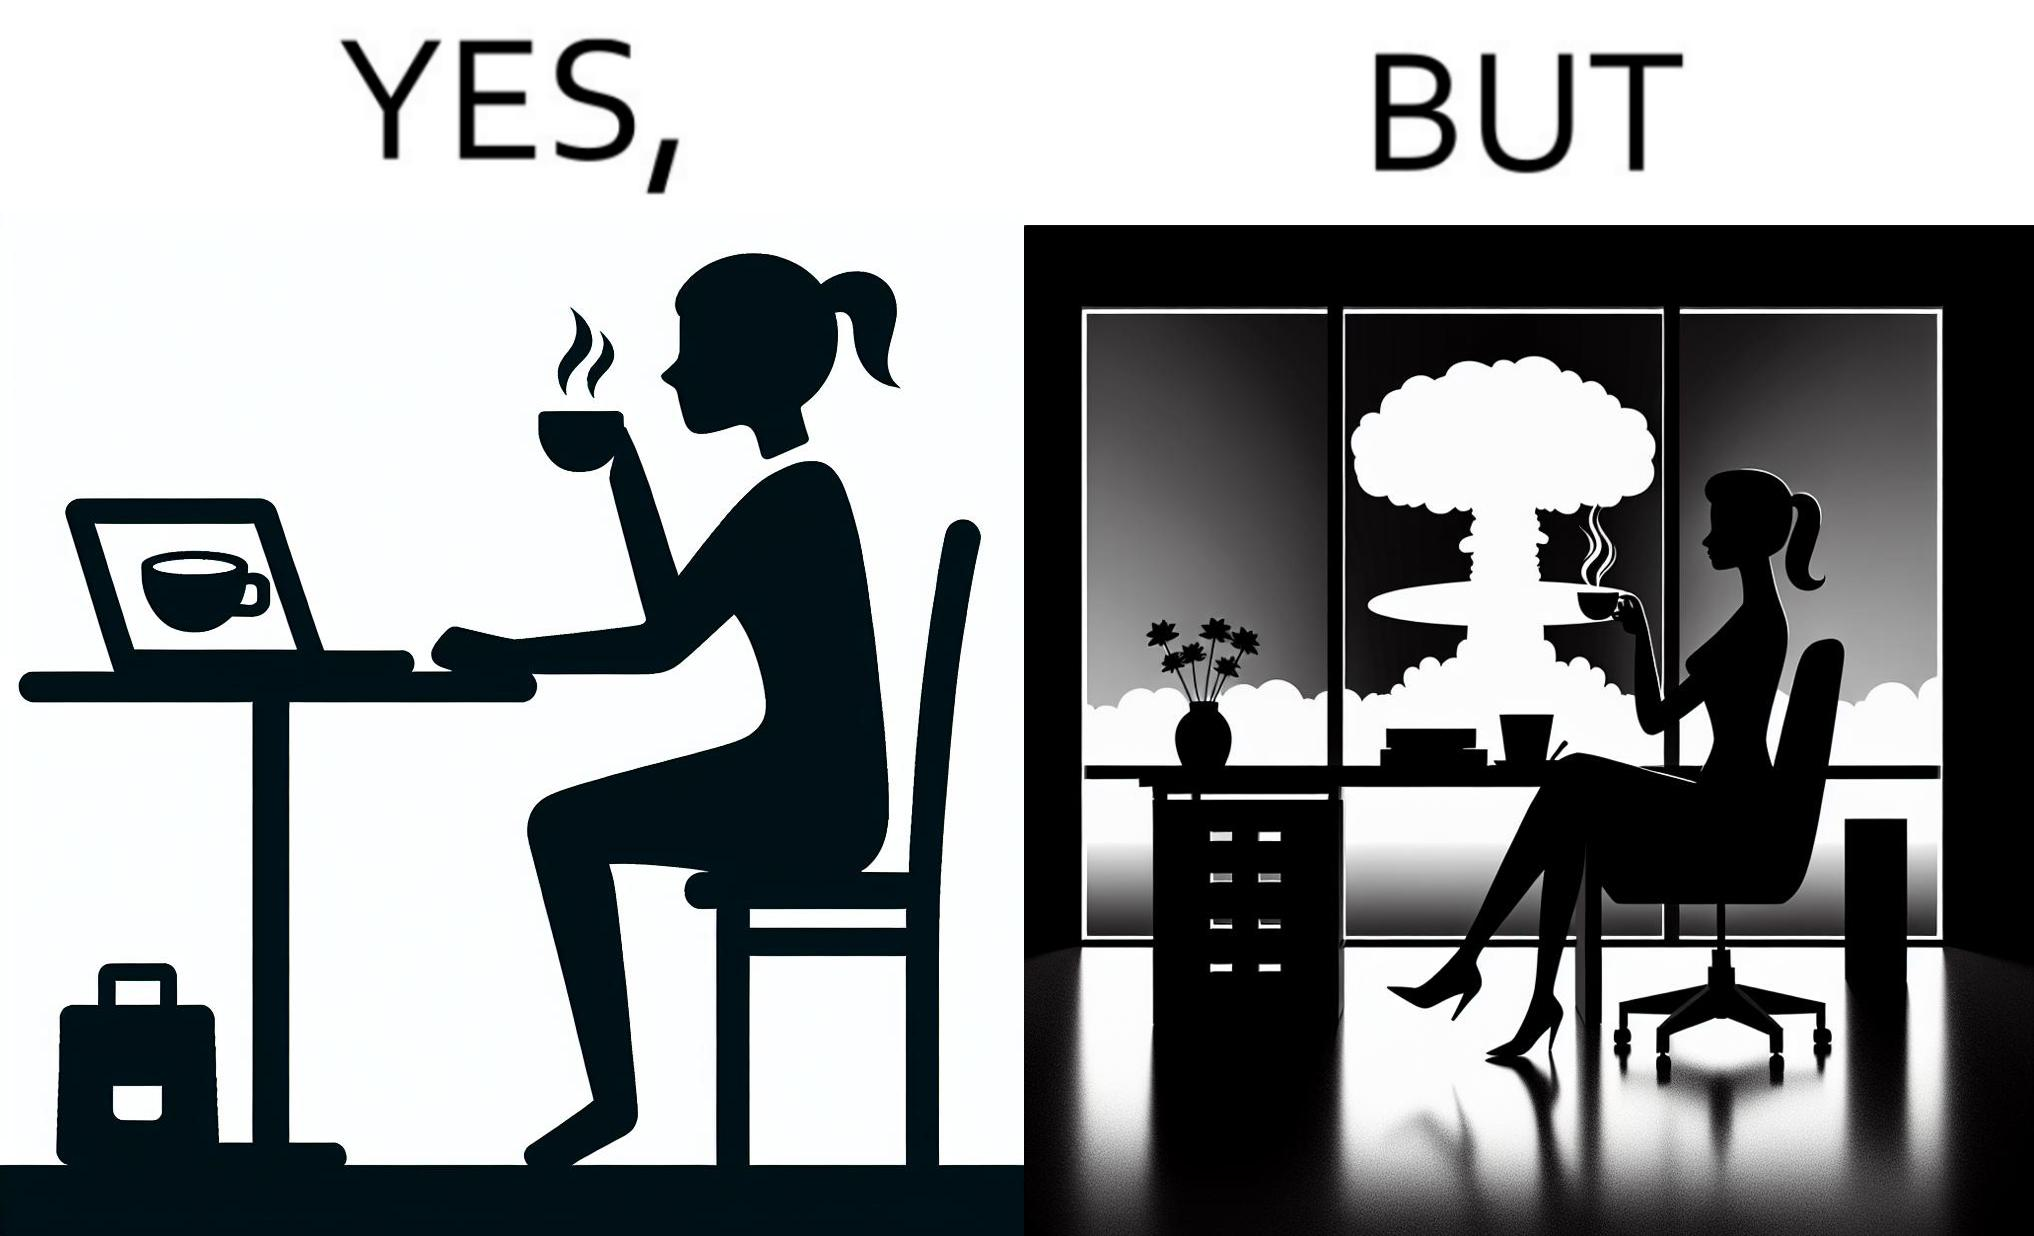Describe the contrast between the left and right parts of this image. In the left part of the image: A woman sipping from a cup in a cafe with her laptop In the right part of the image: A woman sipping from a cup while looking at a nuclear blast from her desk 